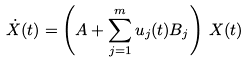<formula> <loc_0><loc_0><loc_500><loc_500>\dot { X } ( t ) = \left ( A + \sum _ { j = 1 } ^ { m } u _ { j } ( t ) B _ { j } \right ) \, X ( t )</formula> 